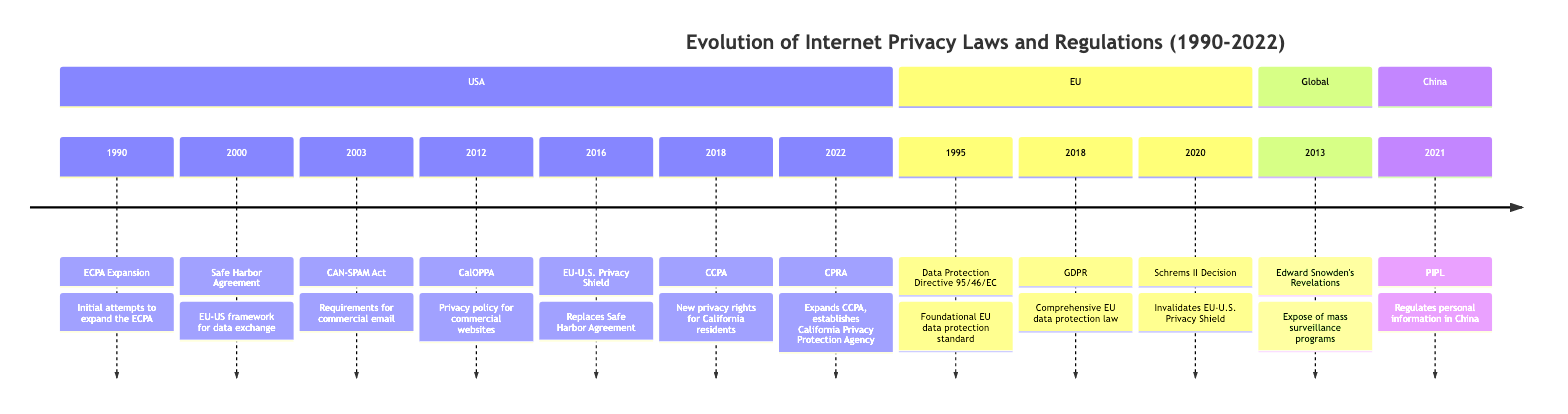What year did the Safe Harbor Agreement take place? According to the timeline, the Safe Harbor Agreement event is listed in the year 2000.
Answer: 2000 What legislation requires commercial websites in California to post a privacy policy? The CalOPPA (California Online Privacy Protection Act) was enacted in 2012, requiring commercial websites to post a privacy policy.
Answer: CalOPPA How many significant privacy events occurred in the EU between 1995 and 2022? The timeline lists three significant privacy events in the EU from 1995 to 2022: the Data Protection Directive in 1995, GDPR in 2018, and the Schrems II Decision in 2020.
Answer: 3 What is the relationship between the Safe Harbor Agreement and the EU-U.S. Privacy Shield? The EU-U.S. Privacy Shield Agreement is described as a replacement for the previously invalidated Safe Harbor Agreement which was put in place to regulate data exchanges.
Answer: Replacement What major global event in 2013 impacted internet privacy discussions? Edward Snowden's revelations in 2013 exposed mass surveillance programs and intensified the debates surrounding internet privacy globally.
Answer: Snowden's Revelations How many total legislative milestones are listed for the USA? In the USA section of the timeline, there are seven legislative milestones listed, starting from 1990 to 2022.
Answer: 7 What year did California pass the California Consumer Privacy Act? The timeline indicates that the California Consumer Privacy Act (CCPA) was enacted in 2018.
Answer: 2018 Which country enacted the Personal Information Protection Law in 2021? The timeline specifies that China enacted the Personal Information Protection Law (PIPL) in 2021 to regulate personal information.
Answer: China What was the main impact of the Schrems II Decision? The event notes that the Schrems II Decision invalidated the EU-U.S. Privacy Shield, significantly affecting transatlantic data transfers and privacy laws.
Answer: Invalidated Privacy Shield 